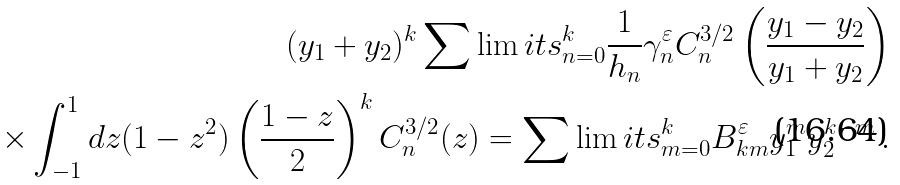Convert formula to latex. <formula><loc_0><loc_0><loc_500><loc_500>( y _ { 1 } + y _ { 2 } ) ^ { k } \sum \lim i t s _ { n = 0 } ^ { k } \frac { 1 } { h _ { n } } \gamma _ { n } ^ { \varepsilon } C _ { n } ^ { 3 / 2 } \left ( \frac { y _ { 1 } - y _ { 2 } } { y _ { 1 } + y _ { 2 } } \right ) \\ \times \int _ { - 1 } ^ { 1 } d z ( 1 - z ^ { 2 } ) \left ( \frac { 1 - z } { 2 } \right ) ^ { k } C _ { n } ^ { 3 / 2 } ( z ) = \sum \lim i t s _ { m = 0 } ^ { k } B _ { k m } ^ { \varepsilon } y _ { 1 } ^ { m } y _ { 2 } ^ { k - m } \, .</formula> 